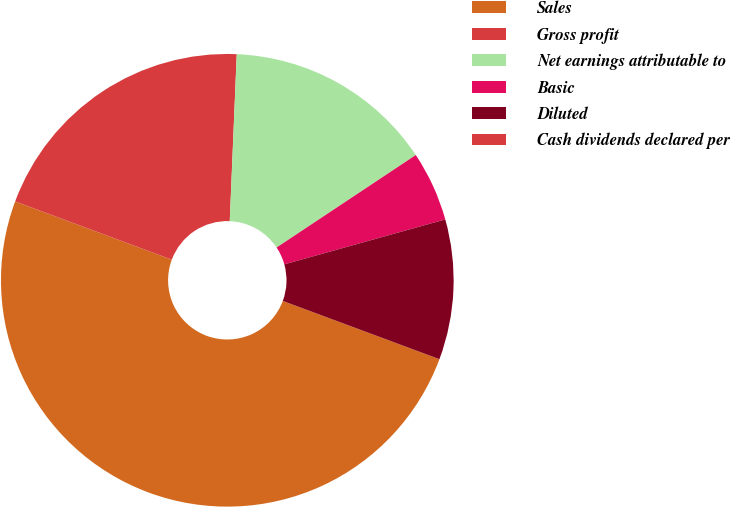<chart> <loc_0><loc_0><loc_500><loc_500><pie_chart><fcel>Sales<fcel>Gross profit<fcel>Net earnings attributable to<fcel>Basic<fcel>Diluted<fcel>Cash dividends declared per<nl><fcel>50.0%<fcel>20.0%<fcel>15.0%<fcel>5.0%<fcel>10.0%<fcel>0.0%<nl></chart> 